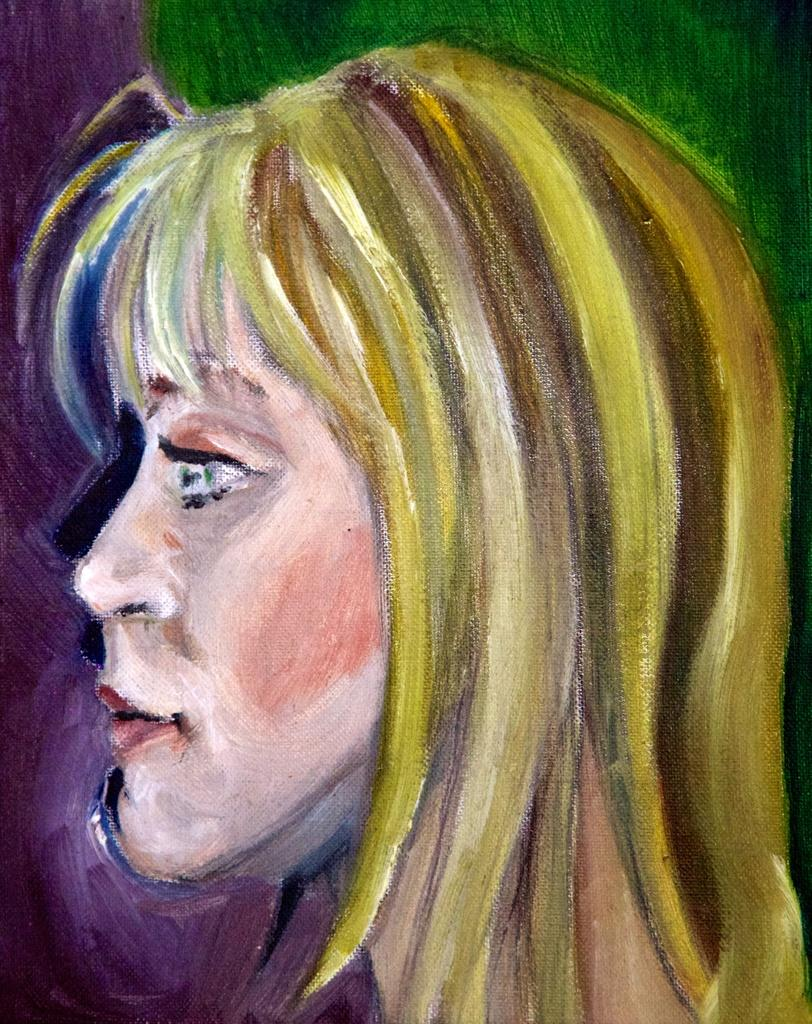What is the main subject of the painting in the image? The main subject of the painting in the image is a woman. What type of quince is depicted in the painting? There is no quince present in the painting; it features a woman. What error can be seen in the painting? There is no error mentioned in the provided facts, and the painting appears to be a complete and accurate representation of the woman. 